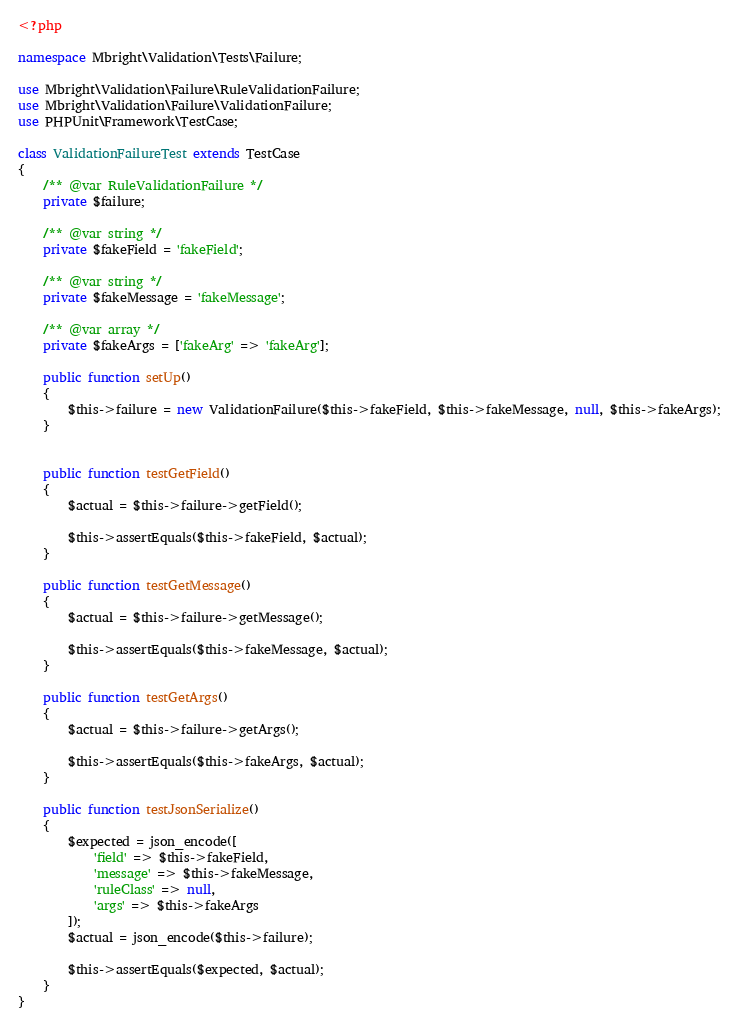Convert code to text. <code><loc_0><loc_0><loc_500><loc_500><_PHP_><?php

namespace Mbright\Validation\Tests\Failure;

use Mbright\Validation\Failure\RuleValidationFailure;
use Mbright\Validation\Failure\ValidationFailure;
use PHPUnit\Framework\TestCase;

class ValidationFailureTest extends TestCase
{
    /** @var RuleValidationFailure */
    private $failure;

    /** @var string */
    private $fakeField = 'fakeField';

    /** @var string */
    private $fakeMessage = 'fakeMessage';

    /** @var array */
    private $fakeArgs = ['fakeArg' => 'fakeArg'];

    public function setUp()
    {
        $this->failure = new ValidationFailure($this->fakeField, $this->fakeMessage, null, $this->fakeArgs);
    }


    public function testGetField()
    {
        $actual = $this->failure->getField();

        $this->assertEquals($this->fakeField, $actual);
    }

    public function testGetMessage()
    {
        $actual = $this->failure->getMessage();

        $this->assertEquals($this->fakeMessage, $actual);
    }

    public function testGetArgs()
    {
        $actual = $this->failure->getArgs();

        $this->assertEquals($this->fakeArgs, $actual);
    }

    public function testJsonSerialize()
    {
        $expected = json_encode([
            'field' => $this->fakeField,
            'message' => $this->fakeMessage,
            'ruleClass' => null,
            'args' => $this->fakeArgs
        ]);
        $actual = json_encode($this->failure);

        $this->assertEquals($expected, $actual);
    }
}
</code> 